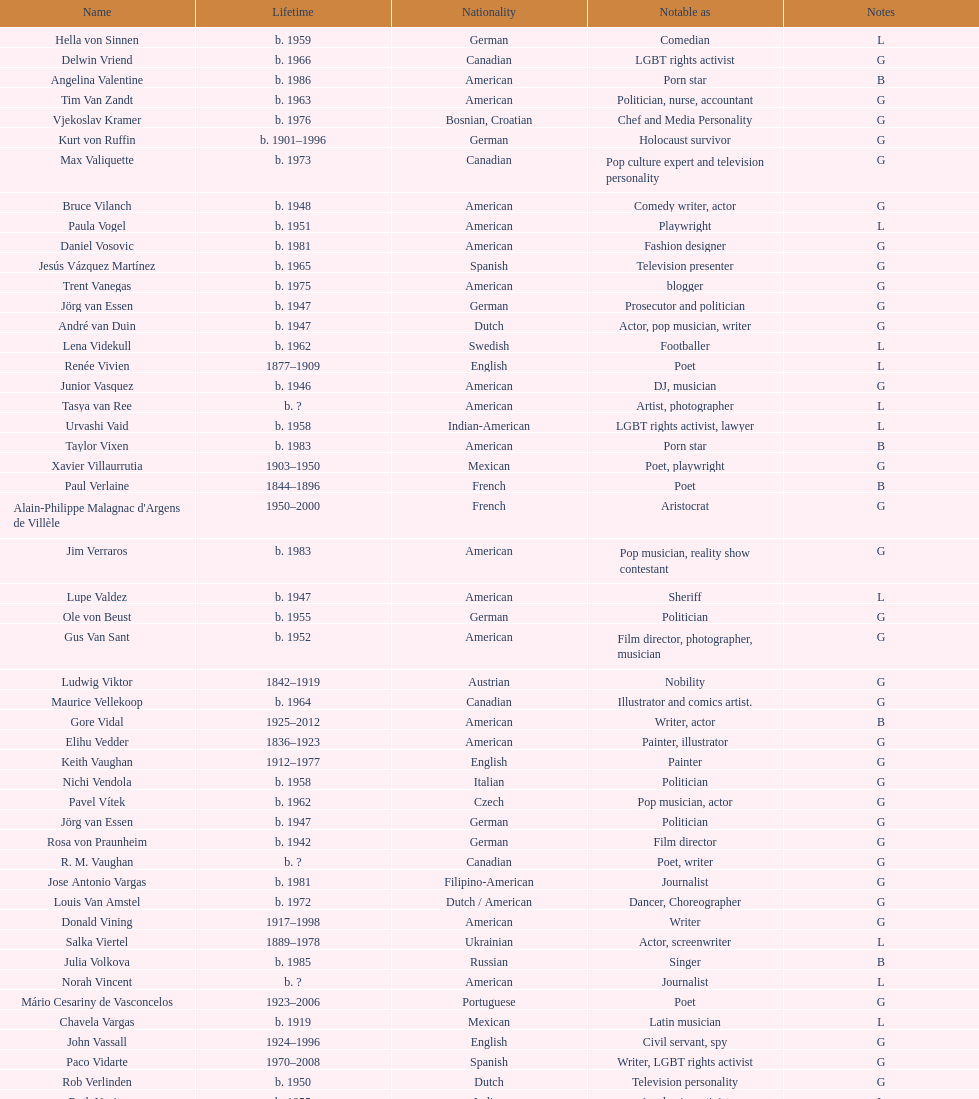What is the number of individuals in this group who were indian? 1. 